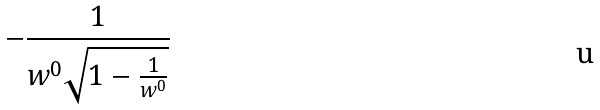<formula> <loc_0><loc_0><loc_500><loc_500>- \frac { 1 } { w ^ { 0 } \sqrt { 1 - \frac { 1 } { w ^ { 0 } } } }</formula> 